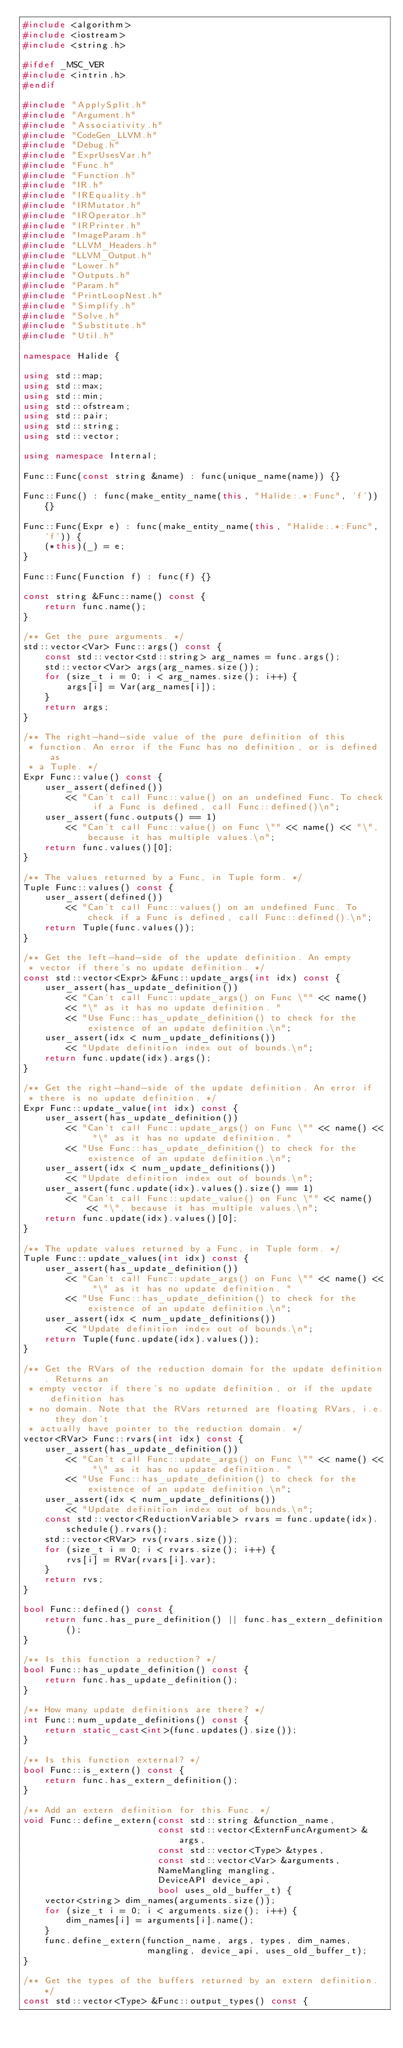Convert code to text. <code><loc_0><loc_0><loc_500><loc_500><_C++_>#include <algorithm>
#include <iostream>
#include <string.h>

#ifdef _MSC_VER
#include <intrin.h>
#endif

#include "ApplySplit.h"
#include "Argument.h"
#include "Associativity.h"
#include "CodeGen_LLVM.h"
#include "Debug.h"
#include "ExprUsesVar.h"
#include "Func.h"
#include "Function.h"
#include "IR.h"
#include "IREquality.h"
#include "IRMutator.h"
#include "IROperator.h"
#include "IRPrinter.h"
#include "ImageParam.h"
#include "LLVM_Headers.h"
#include "LLVM_Output.h"
#include "Lower.h"
#include "Outputs.h"
#include "Param.h"
#include "PrintLoopNest.h"
#include "Simplify.h"
#include "Solve.h"
#include "Substitute.h"
#include "Util.h"

namespace Halide {

using std::map;
using std::max;
using std::min;
using std::ofstream;
using std::pair;
using std::string;
using std::vector;

using namespace Internal;

Func::Func(const string &name) : func(unique_name(name)) {}

Func::Func() : func(make_entity_name(this, "Halide:.*:Func", 'f')) {}

Func::Func(Expr e) : func(make_entity_name(this, "Halide:.*:Func", 'f')) {
    (*this)(_) = e;
}

Func::Func(Function f) : func(f) {}

const string &Func::name() const {
    return func.name();
}

/** Get the pure arguments. */
std::vector<Var> Func::args() const {
    const std::vector<std::string> arg_names = func.args();
    std::vector<Var> args(arg_names.size());
    for (size_t i = 0; i < arg_names.size(); i++) {
        args[i] = Var(arg_names[i]);
    }
    return args;
}

/** The right-hand-side value of the pure definition of this
 * function. An error if the Func has no definition, or is defined as
 * a Tuple. */
Expr Func::value() const {
    user_assert(defined())
        << "Can't call Func::value() on an undefined Func. To check if a Func is defined, call Func::defined()\n";
    user_assert(func.outputs() == 1)
        << "Can't call Func::value() on Func \"" << name() << "\", because it has multiple values.\n";
    return func.values()[0];
}

/** The values returned by a Func, in Tuple form. */
Tuple Func::values() const {
    user_assert(defined())
        << "Can't call Func::values() on an undefined Func. To check if a Func is defined, call Func::defined().\n";
    return Tuple(func.values());
}

/** Get the left-hand-side of the update definition. An empty
 * vector if there's no update definition. */
const std::vector<Expr> &Func::update_args(int idx) const {
    user_assert(has_update_definition())
        << "Can't call Func::update_args() on Func \"" << name()
        << "\" as it has no update definition. "
        << "Use Func::has_update_definition() to check for the existence of an update definition.\n";
    user_assert(idx < num_update_definitions())
        << "Update definition index out of bounds.\n";
    return func.update(idx).args();
}

/** Get the right-hand-side of the update definition. An error if
 * there is no update definition. */
Expr Func::update_value(int idx) const {
    user_assert(has_update_definition())
        << "Can't call Func::update_args() on Func \"" << name() << "\" as it has no update definition. "
        << "Use Func::has_update_definition() to check for the existence of an update definition.\n";
    user_assert(idx < num_update_definitions())
        << "Update definition index out of bounds.\n";
    user_assert(func.update(idx).values().size() == 1)
        << "Can't call Func::update_value() on Func \"" << name() << "\", because it has multiple values.\n";
    return func.update(idx).values()[0];
}

/** The update values returned by a Func, in Tuple form. */
Tuple Func::update_values(int idx) const {
    user_assert(has_update_definition())
        << "Can't call Func::update_args() on Func \"" << name() << "\" as it has no update definition. "
        << "Use Func::has_update_definition() to check for the existence of an update definition.\n";
    user_assert(idx < num_update_definitions())
        << "Update definition index out of bounds.\n";
    return Tuple(func.update(idx).values());
}

/** Get the RVars of the reduction domain for the update definition. Returns an
 * empty vector if there's no update definition, or if the update definition has
 * no domain. Note that the RVars returned are floating RVars, i.e. they don't
 * actually have pointer to the reduction domain. */
vector<RVar> Func::rvars(int idx) const {
    user_assert(has_update_definition())
        << "Can't call Func::update_args() on Func \"" << name() << "\" as it has no update definition. "
        << "Use Func::has_update_definition() to check for the existence of an update definition.\n";
    user_assert(idx < num_update_definitions())
        << "Update definition index out of bounds.\n";
    const std::vector<ReductionVariable> rvars = func.update(idx).schedule().rvars();
    std::vector<RVar> rvs(rvars.size());
    for (size_t i = 0; i < rvars.size(); i++) {
        rvs[i] = RVar(rvars[i].var);
    }
    return rvs;
}

bool Func::defined() const {
    return func.has_pure_definition() || func.has_extern_definition();
}

/** Is this function a reduction? */
bool Func::has_update_definition() const {
    return func.has_update_definition();
}

/** How many update definitions are there? */
int Func::num_update_definitions() const {
    return static_cast<int>(func.updates().size());
}

/** Is this function external? */
bool Func::is_extern() const {
    return func.has_extern_definition();
}

/** Add an extern definition for this Func. */
void Func::define_extern(const std::string &function_name,
                         const std::vector<ExternFuncArgument> &args,
                         const std::vector<Type> &types,
                         const std::vector<Var> &arguments,
                         NameMangling mangling,
                         DeviceAPI device_api,
                         bool uses_old_buffer_t) {
    vector<string> dim_names(arguments.size());
    for (size_t i = 0; i < arguments.size(); i++) {
        dim_names[i] = arguments[i].name();
    }
    func.define_extern(function_name, args, types, dim_names,
                       mangling, device_api, uses_old_buffer_t);
}

/** Get the types of the buffers returned by an extern definition. */
const std::vector<Type> &Func::output_types() const {</code> 